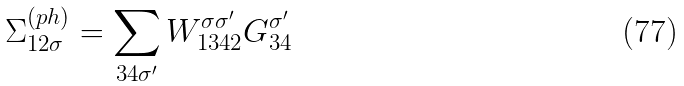Convert formula to latex. <formula><loc_0><loc_0><loc_500><loc_500>\Sigma _ { 1 2 \sigma } ^ { ( p h ) } = \sum _ { 3 4 \sigma ^ { \prime } } W _ { 1 3 4 2 } ^ { \sigma \sigma ^ { \prime } } G _ { 3 4 } ^ { \sigma ^ { \prime } }</formula> 